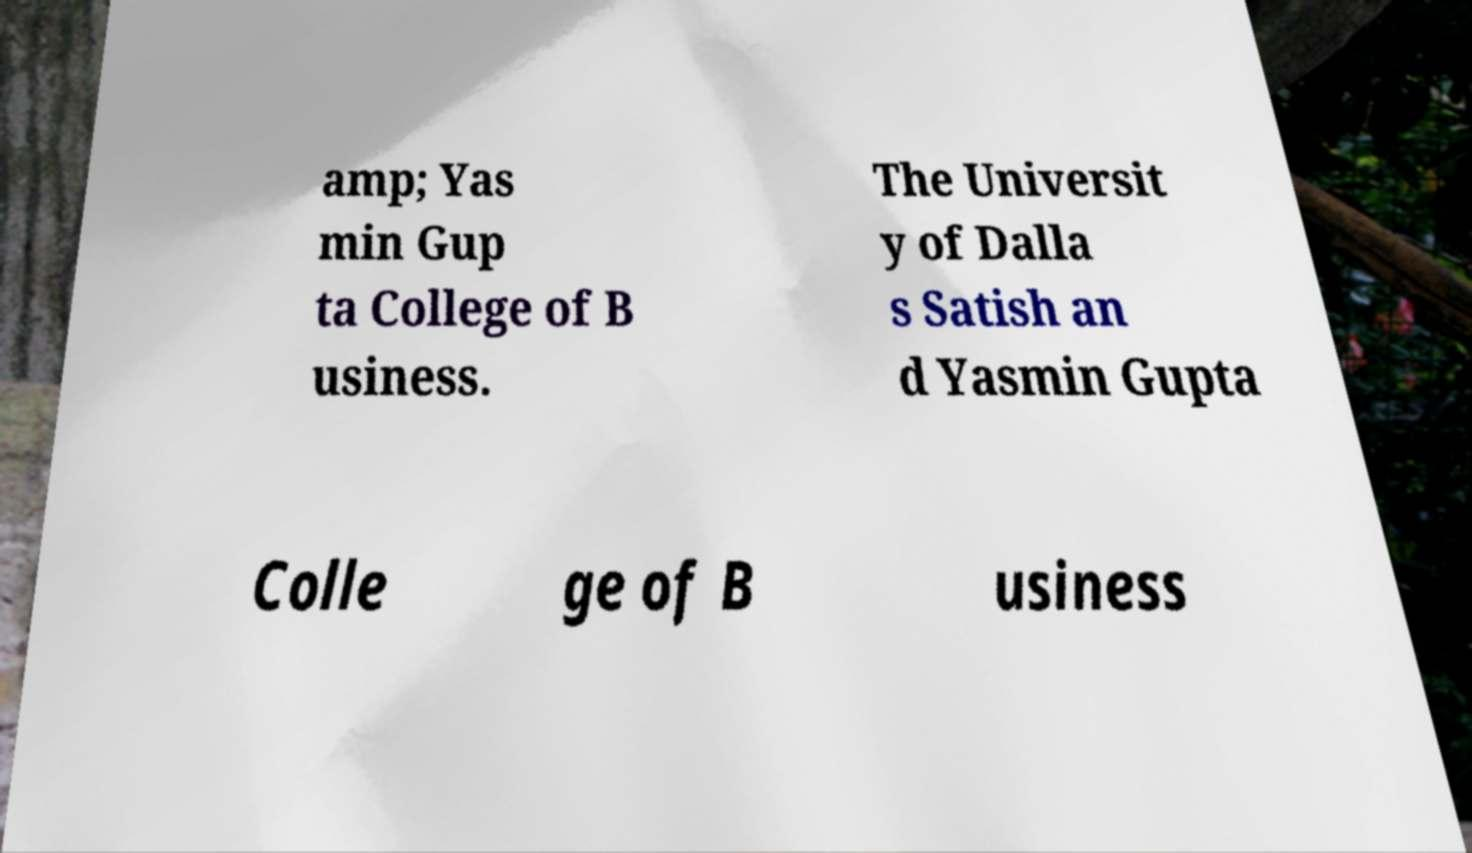Please read and relay the text visible in this image. What does it say? amp; Yas min Gup ta College of B usiness. The Universit y of Dalla s Satish an d Yasmin Gupta Colle ge of B usiness 